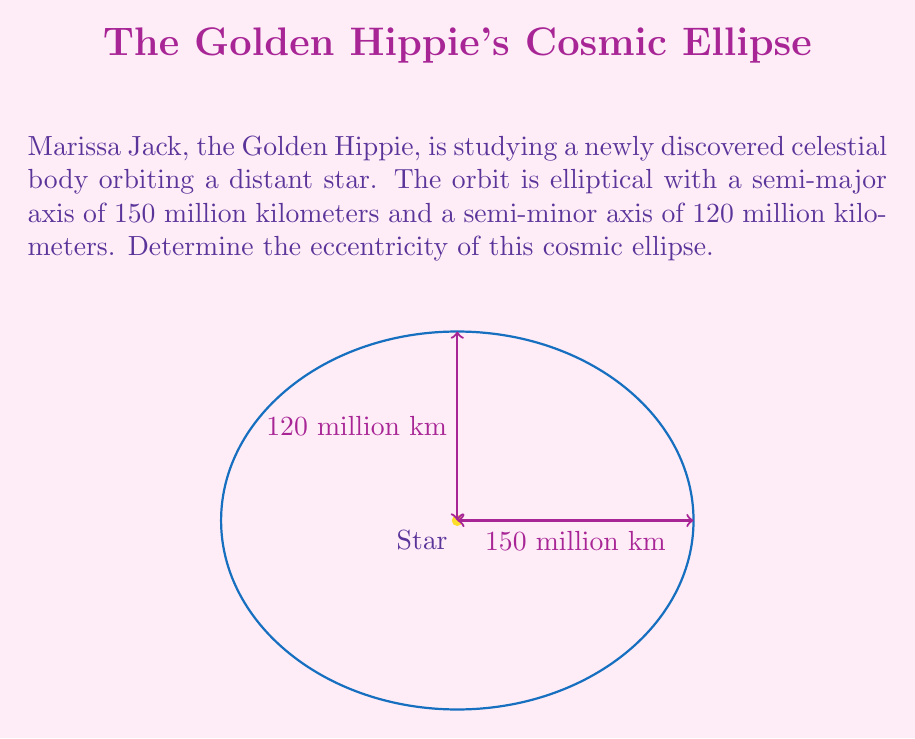Show me your answer to this math problem. Let's approach this step-by-step:

1) The eccentricity of an ellipse, denoted as $e$, is defined as:

   $$e = \sqrt{1 - \frac{b^2}{a^2}}$$

   where $a$ is the semi-major axis and $b$ is the semi-minor axis.

2) We are given:
   $a = 150$ million km
   $b = 120$ million km

3) Let's substitute these values into the equation:

   $$e = \sqrt{1 - \frac{(120)^2}{(150)^2}}$$

4) Simplify inside the parentheses:

   $$e = \sqrt{1 - \frac{14400}{22500}}$$

5) Perform the division:

   $$e = \sqrt{1 - 0.64}$$

6) Subtract:

   $$e = \sqrt{0.36}$$

7) Take the square root:

   $$e = 0.6$$

Thus, the eccentricity of the Golden Hippie's cosmic ellipse is 0.6.
Answer: $0.6$ 